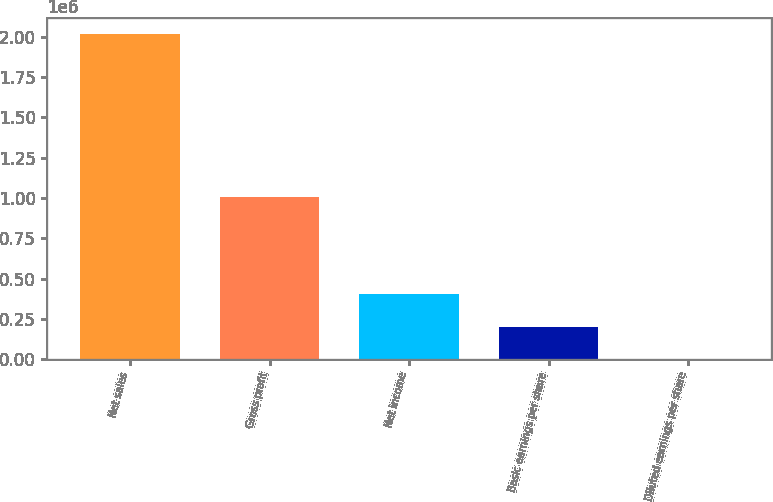Convert chart. <chart><loc_0><loc_0><loc_500><loc_500><bar_chart><fcel>Net sales<fcel>Gross profit<fcel>Net income<fcel>Basic earnings per share<fcel>Diluted earnings per share<nl><fcel>2.0153e+06<fcel>1.00821e+06<fcel>403062<fcel>201532<fcel>1.65<nl></chart> 